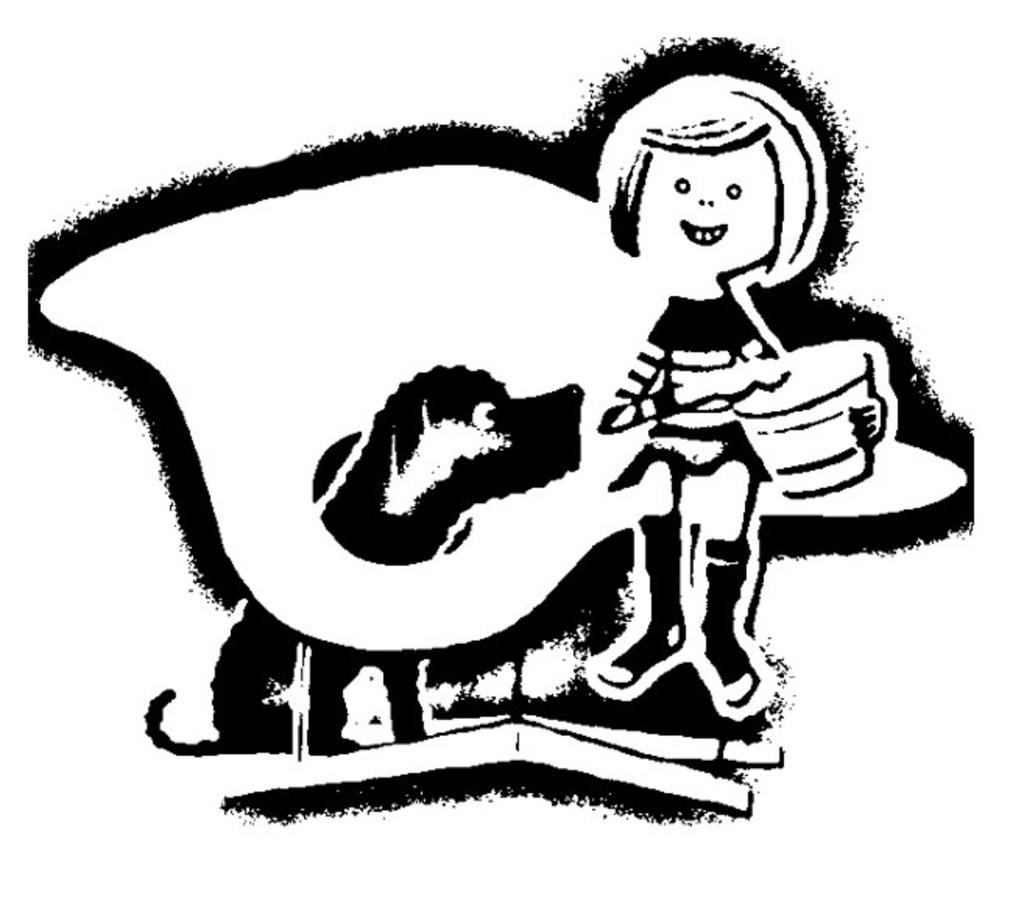What type of characters are depicted in the image? There is a cartoon image of a person and a cartoon image of a dog in the picture. What is the color of the background in the image? The background of the image is white. What type of muscle is being flexed by the dog in the image? There is no muscle being flexed by the dog in the image, as it is a cartoon image of a dog and not a real dog. 